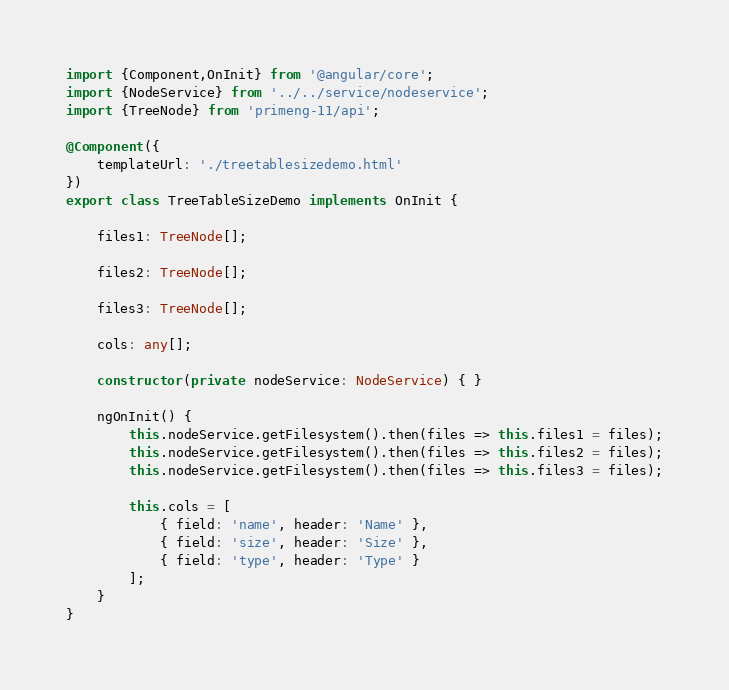<code> <loc_0><loc_0><loc_500><loc_500><_TypeScript_>import {Component,OnInit} from '@angular/core';
import {NodeService} from '../../service/nodeservice';
import {TreeNode} from 'primeng-11/api';

@Component({
    templateUrl: './treetablesizedemo.html'
})
export class TreeTableSizeDemo implements OnInit {

    files1: TreeNode[];

    files2: TreeNode[];

    files3: TreeNode[];

    cols: any[];

    constructor(private nodeService: NodeService) { }

    ngOnInit() {
        this.nodeService.getFilesystem().then(files => this.files1 = files);
        this.nodeService.getFilesystem().then(files => this.files2 = files);
        this.nodeService.getFilesystem().then(files => this.files3 = files);

        this.cols = [
            { field: 'name', header: 'Name' },
            { field: 'size', header: 'Size' },
            { field: 'type', header: 'Type' }
        ];
    }
}
</code> 